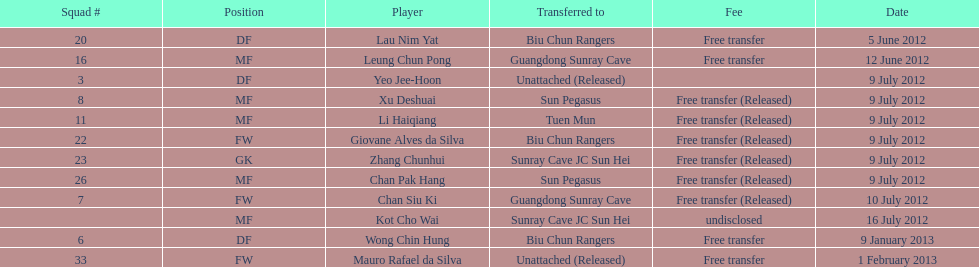What is the overall count of players mentioned? 12. 